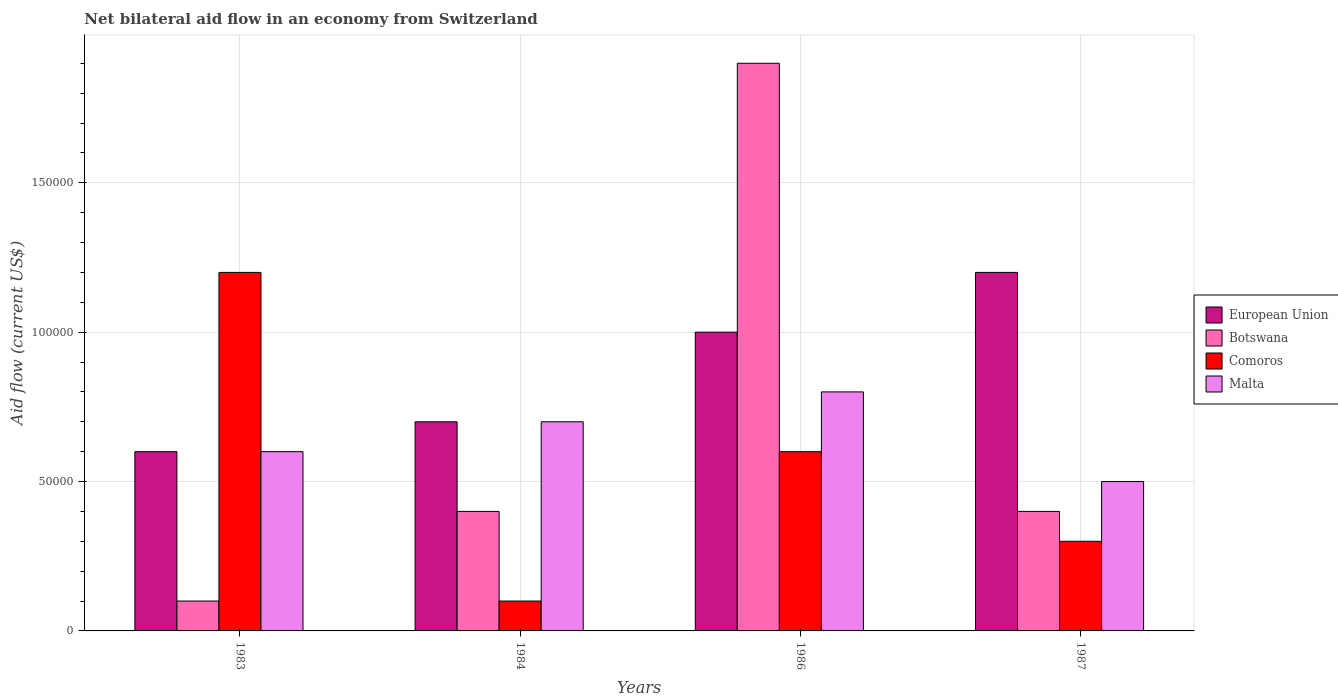How many different coloured bars are there?
Keep it short and to the point. 4. How many groups of bars are there?
Your response must be concise. 4. How many bars are there on the 4th tick from the right?
Your answer should be very brief. 4. Across all years, what is the maximum net bilateral aid flow in Malta?
Provide a short and direct response. 8.00e+04. In which year was the net bilateral aid flow in Comoros maximum?
Offer a very short reply. 1983. In which year was the net bilateral aid flow in Comoros minimum?
Give a very brief answer. 1984. What is the total net bilateral aid flow in Botswana in the graph?
Ensure brevity in your answer.  2.80e+05. What is the average net bilateral aid flow in Malta per year?
Provide a succinct answer. 6.50e+04. In how many years, is the net bilateral aid flow in Malta greater than 50000 US$?
Give a very brief answer. 3. What is the ratio of the net bilateral aid flow in Malta in 1984 to that in 1986?
Offer a terse response. 0.88. Is the net bilateral aid flow in Botswana in 1983 less than that in 1987?
Provide a short and direct response. Yes. Is the sum of the net bilateral aid flow in Comoros in 1984 and 1986 greater than the maximum net bilateral aid flow in Malta across all years?
Make the answer very short. No. What does the 1st bar from the right in 1983 represents?
Give a very brief answer. Malta. Are all the bars in the graph horizontal?
Give a very brief answer. No. How many years are there in the graph?
Offer a very short reply. 4. What is the difference between two consecutive major ticks on the Y-axis?
Your answer should be very brief. 5.00e+04. Does the graph contain any zero values?
Provide a short and direct response. No. Does the graph contain grids?
Provide a short and direct response. Yes. How many legend labels are there?
Give a very brief answer. 4. What is the title of the graph?
Your answer should be compact. Net bilateral aid flow in an economy from Switzerland. Does "Latin America(developing only)" appear as one of the legend labels in the graph?
Your answer should be compact. No. What is the label or title of the X-axis?
Keep it short and to the point. Years. What is the Aid flow (current US$) in European Union in 1983?
Provide a short and direct response. 6.00e+04. What is the Aid flow (current US$) of European Union in 1984?
Offer a terse response. 7.00e+04. What is the Aid flow (current US$) in Botswana in 1984?
Give a very brief answer. 4.00e+04. What is the Aid flow (current US$) of Malta in 1984?
Your answer should be very brief. 7.00e+04. What is the Aid flow (current US$) in European Union in 1986?
Provide a succinct answer. 1.00e+05. What is the Aid flow (current US$) in Botswana in 1986?
Give a very brief answer. 1.90e+05. What is the Aid flow (current US$) of Malta in 1986?
Provide a short and direct response. 8.00e+04. What is the Aid flow (current US$) of European Union in 1987?
Ensure brevity in your answer.  1.20e+05. What is the Aid flow (current US$) of Comoros in 1987?
Provide a short and direct response. 3.00e+04. What is the Aid flow (current US$) in Malta in 1987?
Make the answer very short. 5.00e+04. Across all years, what is the maximum Aid flow (current US$) of Comoros?
Give a very brief answer. 1.20e+05. Across all years, what is the maximum Aid flow (current US$) of Malta?
Your answer should be compact. 8.00e+04. What is the total Aid flow (current US$) of Botswana in the graph?
Provide a short and direct response. 2.80e+05. What is the total Aid flow (current US$) of Comoros in the graph?
Keep it short and to the point. 2.20e+05. What is the total Aid flow (current US$) in Malta in the graph?
Keep it short and to the point. 2.60e+05. What is the difference between the Aid flow (current US$) of European Union in 1983 and that in 1984?
Keep it short and to the point. -10000. What is the difference between the Aid flow (current US$) in Comoros in 1983 and that in 1984?
Your response must be concise. 1.10e+05. What is the difference between the Aid flow (current US$) in Malta in 1983 and that in 1984?
Provide a succinct answer. -10000. What is the difference between the Aid flow (current US$) in European Union in 1983 and that in 1986?
Make the answer very short. -4.00e+04. What is the difference between the Aid flow (current US$) in European Union in 1983 and that in 1987?
Offer a terse response. -6.00e+04. What is the difference between the Aid flow (current US$) in Botswana in 1984 and that in 1986?
Ensure brevity in your answer.  -1.50e+05. What is the difference between the Aid flow (current US$) in Comoros in 1984 and that in 1986?
Offer a terse response. -5.00e+04. What is the difference between the Aid flow (current US$) in Malta in 1984 and that in 1986?
Offer a terse response. -10000. What is the difference between the Aid flow (current US$) of Malta in 1984 and that in 1987?
Keep it short and to the point. 2.00e+04. What is the difference between the Aid flow (current US$) in European Union in 1986 and that in 1987?
Ensure brevity in your answer.  -2.00e+04. What is the difference between the Aid flow (current US$) of Comoros in 1986 and that in 1987?
Your answer should be very brief. 3.00e+04. What is the difference between the Aid flow (current US$) of Malta in 1986 and that in 1987?
Your response must be concise. 3.00e+04. What is the difference between the Aid flow (current US$) of European Union in 1983 and the Aid flow (current US$) of Comoros in 1984?
Give a very brief answer. 5.00e+04. What is the difference between the Aid flow (current US$) in Botswana in 1983 and the Aid flow (current US$) in Comoros in 1984?
Keep it short and to the point. 0. What is the difference between the Aid flow (current US$) of Botswana in 1983 and the Aid flow (current US$) of Malta in 1984?
Make the answer very short. -6.00e+04. What is the difference between the Aid flow (current US$) in European Union in 1983 and the Aid flow (current US$) in Comoros in 1986?
Provide a succinct answer. 0. What is the difference between the Aid flow (current US$) in European Union in 1983 and the Aid flow (current US$) in Malta in 1986?
Your answer should be compact. -2.00e+04. What is the difference between the Aid flow (current US$) in European Union in 1983 and the Aid flow (current US$) in Botswana in 1987?
Offer a very short reply. 2.00e+04. What is the difference between the Aid flow (current US$) of European Union in 1983 and the Aid flow (current US$) of Malta in 1987?
Provide a succinct answer. 10000. What is the difference between the Aid flow (current US$) of European Union in 1984 and the Aid flow (current US$) of Botswana in 1986?
Offer a very short reply. -1.20e+05. What is the difference between the Aid flow (current US$) of European Union in 1984 and the Aid flow (current US$) of Malta in 1986?
Offer a very short reply. -10000. What is the difference between the Aid flow (current US$) of European Union in 1984 and the Aid flow (current US$) of Botswana in 1987?
Give a very brief answer. 3.00e+04. What is the difference between the Aid flow (current US$) of European Union in 1984 and the Aid flow (current US$) of Comoros in 1987?
Offer a terse response. 4.00e+04. What is the difference between the Aid flow (current US$) in Comoros in 1984 and the Aid flow (current US$) in Malta in 1987?
Give a very brief answer. -4.00e+04. What is the difference between the Aid flow (current US$) in European Union in 1986 and the Aid flow (current US$) in Comoros in 1987?
Your answer should be compact. 7.00e+04. What is the difference between the Aid flow (current US$) in European Union in 1986 and the Aid flow (current US$) in Malta in 1987?
Ensure brevity in your answer.  5.00e+04. What is the difference between the Aid flow (current US$) of Botswana in 1986 and the Aid flow (current US$) of Malta in 1987?
Offer a very short reply. 1.40e+05. What is the average Aid flow (current US$) in European Union per year?
Your answer should be very brief. 8.75e+04. What is the average Aid flow (current US$) in Botswana per year?
Ensure brevity in your answer.  7.00e+04. What is the average Aid flow (current US$) of Comoros per year?
Your response must be concise. 5.50e+04. What is the average Aid flow (current US$) of Malta per year?
Offer a terse response. 6.50e+04. In the year 1983, what is the difference between the Aid flow (current US$) of Botswana and Aid flow (current US$) of Comoros?
Your answer should be very brief. -1.10e+05. In the year 1983, what is the difference between the Aid flow (current US$) in Botswana and Aid flow (current US$) in Malta?
Make the answer very short. -5.00e+04. In the year 1984, what is the difference between the Aid flow (current US$) of European Union and Aid flow (current US$) of Botswana?
Ensure brevity in your answer.  3.00e+04. In the year 1984, what is the difference between the Aid flow (current US$) of European Union and Aid flow (current US$) of Comoros?
Provide a succinct answer. 6.00e+04. In the year 1984, what is the difference between the Aid flow (current US$) of Comoros and Aid flow (current US$) of Malta?
Offer a very short reply. -6.00e+04. In the year 1986, what is the difference between the Aid flow (current US$) of Comoros and Aid flow (current US$) of Malta?
Your answer should be compact. -2.00e+04. In the year 1987, what is the difference between the Aid flow (current US$) of European Union and Aid flow (current US$) of Botswana?
Ensure brevity in your answer.  8.00e+04. In the year 1987, what is the difference between the Aid flow (current US$) of European Union and Aid flow (current US$) of Comoros?
Ensure brevity in your answer.  9.00e+04. In the year 1987, what is the difference between the Aid flow (current US$) of Botswana and Aid flow (current US$) of Comoros?
Provide a succinct answer. 10000. In the year 1987, what is the difference between the Aid flow (current US$) of Botswana and Aid flow (current US$) of Malta?
Provide a succinct answer. -10000. What is the ratio of the Aid flow (current US$) in European Union in 1983 to that in 1984?
Your answer should be compact. 0.86. What is the ratio of the Aid flow (current US$) of Comoros in 1983 to that in 1984?
Make the answer very short. 12. What is the ratio of the Aid flow (current US$) in Malta in 1983 to that in 1984?
Offer a very short reply. 0.86. What is the ratio of the Aid flow (current US$) in Botswana in 1983 to that in 1986?
Your response must be concise. 0.05. What is the ratio of the Aid flow (current US$) of Comoros in 1983 to that in 1986?
Your response must be concise. 2. What is the ratio of the Aid flow (current US$) in Malta in 1983 to that in 1986?
Provide a short and direct response. 0.75. What is the ratio of the Aid flow (current US$) of Malta in 1983 to that in 1987?
Your answer should be very brief. 1.2. What is the ratio of the Aid flow (current US$) of Botswana in 1984 to that in 1986?
Keep it short and to the point. 0.21. What is the ratio of the Aid flow (current US$) of European Union in 1984 to that in 1987?
Give a very brief answer. 0.58. What is the ratio of the Aid flow (current US$) of Malta in 1984 to that in 1987?
Offer a very short reply. 1.4. What is the ratio of the Aid flow (current US$) of Botswana in 1986 to that in 1987?
Your answer should be very brief. 4.75. What is the difference between the highest and the second highest Aid flow (current US$) in European Union?
Offer a terse response. 2.00e+04. What is the difference between the highest and the second highest Aid flow (current US$) of Botswana?
Provide a succinct answer. 1.50e+05. What is the difference between the highest and the lowest Aid flow (current US$) in European Union?
Offer a terse response. 6.00e+04. What is the difference between the highest and the lowest Aid flow (current US$) of Botswana?
Keep it short and to the point. 1.80e+05. What is the difference between the highest and the lowest Aid flow (current US$) of Comoros?
Give a very brief answer. 1.10e+05. 